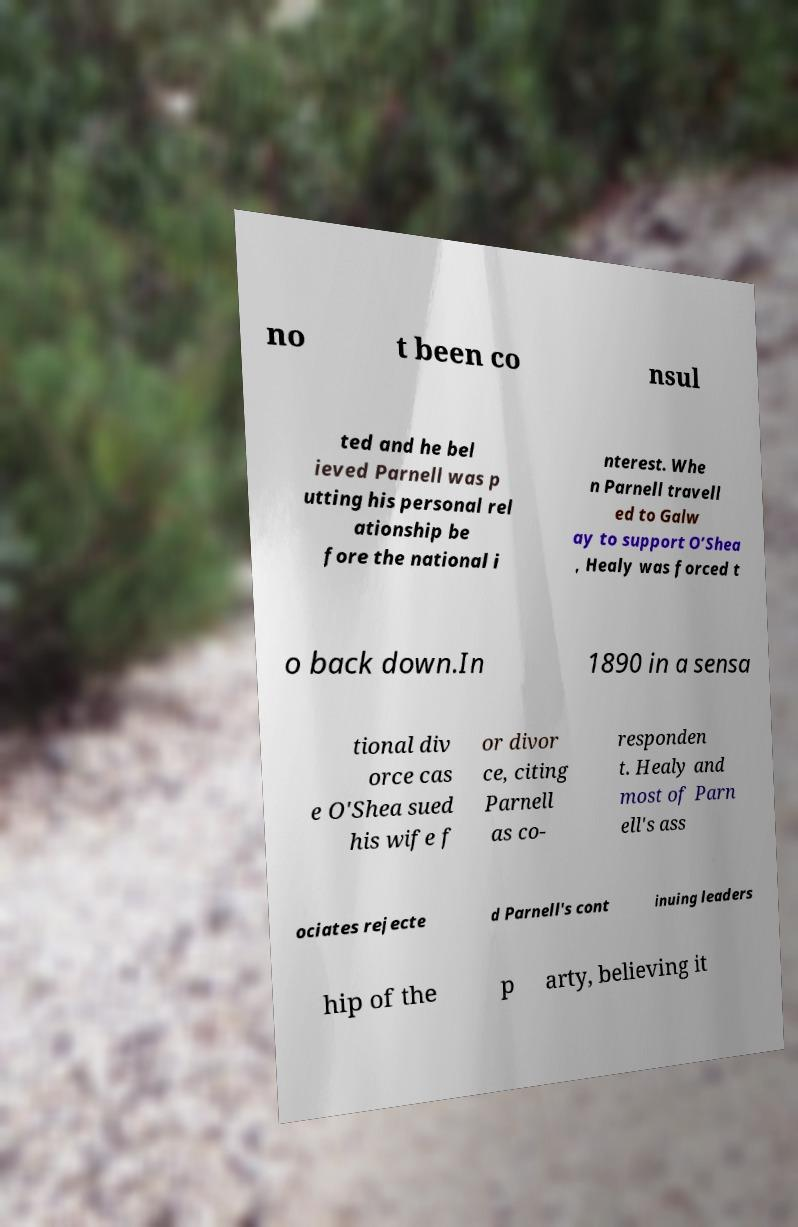Please identify and transcribe the text found in this image. no t been co nsul ted and he bel ieved Parnell was p utting his personal rel ationship be fore the national i nterest. Whe n Parnell travell ed to Galw ay to support O’Shea , Healy was forced t o back down.In 1890 in a sensa tional div orce cas e O'Shea sued his wife f or divor ce, citing Parnell as co- responden t. Healy and most of Parn ell's ass ociates rejecte d Parnell's cont inuing leaders hip of the p arty, believing it 